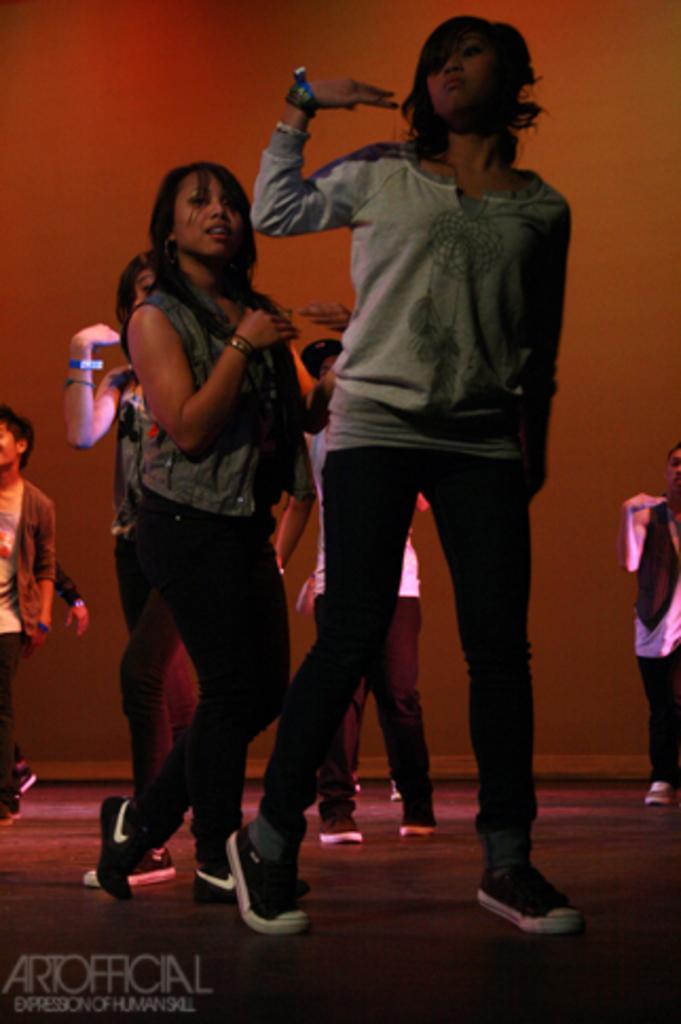How would you summarize this image in a sentence or two? In this image we can see a group of people standing on the floor. One woman is wearing grey t shirt. At the bottom we can see some text. 